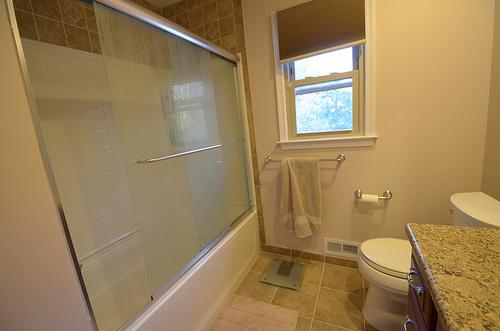Explain some of the floor and wall features of the bathroom in the image. The bathroom floor has light brown square tiles and a metal panel, while the walls are white and have a panel of brown tiles over white tiles. Provide a brief description of the counter and vanity area in the bathroom. A granite countertop with stone vanity top and wooden cabinets next to the toilet, featuring a dark brown wooden drawer. Comment on the window in the image and what can be seen outside. A bathroom window with a partially covered view of trees outside, and the photo taken in the daytime. Describe the features of the bathroom related to cleanliness and organization. The bathroom appears clean, organized, and well-kept with neatly folded towels, pulled-up blinds, and toilet paper in place. Mention the primary colors featured in the bathroom and the key elements they correspond to. White (toilet, wall), tan (tiles, window shade), brown (tiles, granite countertop, wooden cabinets, bath mat). Briefly describe the major objects seen in the image. White toilet, granite countertop, wooden cabinets, light brown tiles, glass doors, window overlooking trees, bathroom in white, tan, and brown. Provide a general description of the bathroom setting in the image. A cozy bathroom with white, tan, and brown elements, featuring wooden cabinets, light brown tiles, a granite countertop, and a window overlooking trees. Mention any digital or modern features that can be seen in the image. A clear scale with digital readout and a white vent in the wall. Comment on the presence of any rugs, mats, or towels in the image. There is a cream-colored bath mat, a light pink bathroom rug, and a towel hanging on a rack. Describe the toilet area in the image. A white toilet is set into a corner with the seat down, with a toilet paper holder attached to the wall holding a partially used roll. 